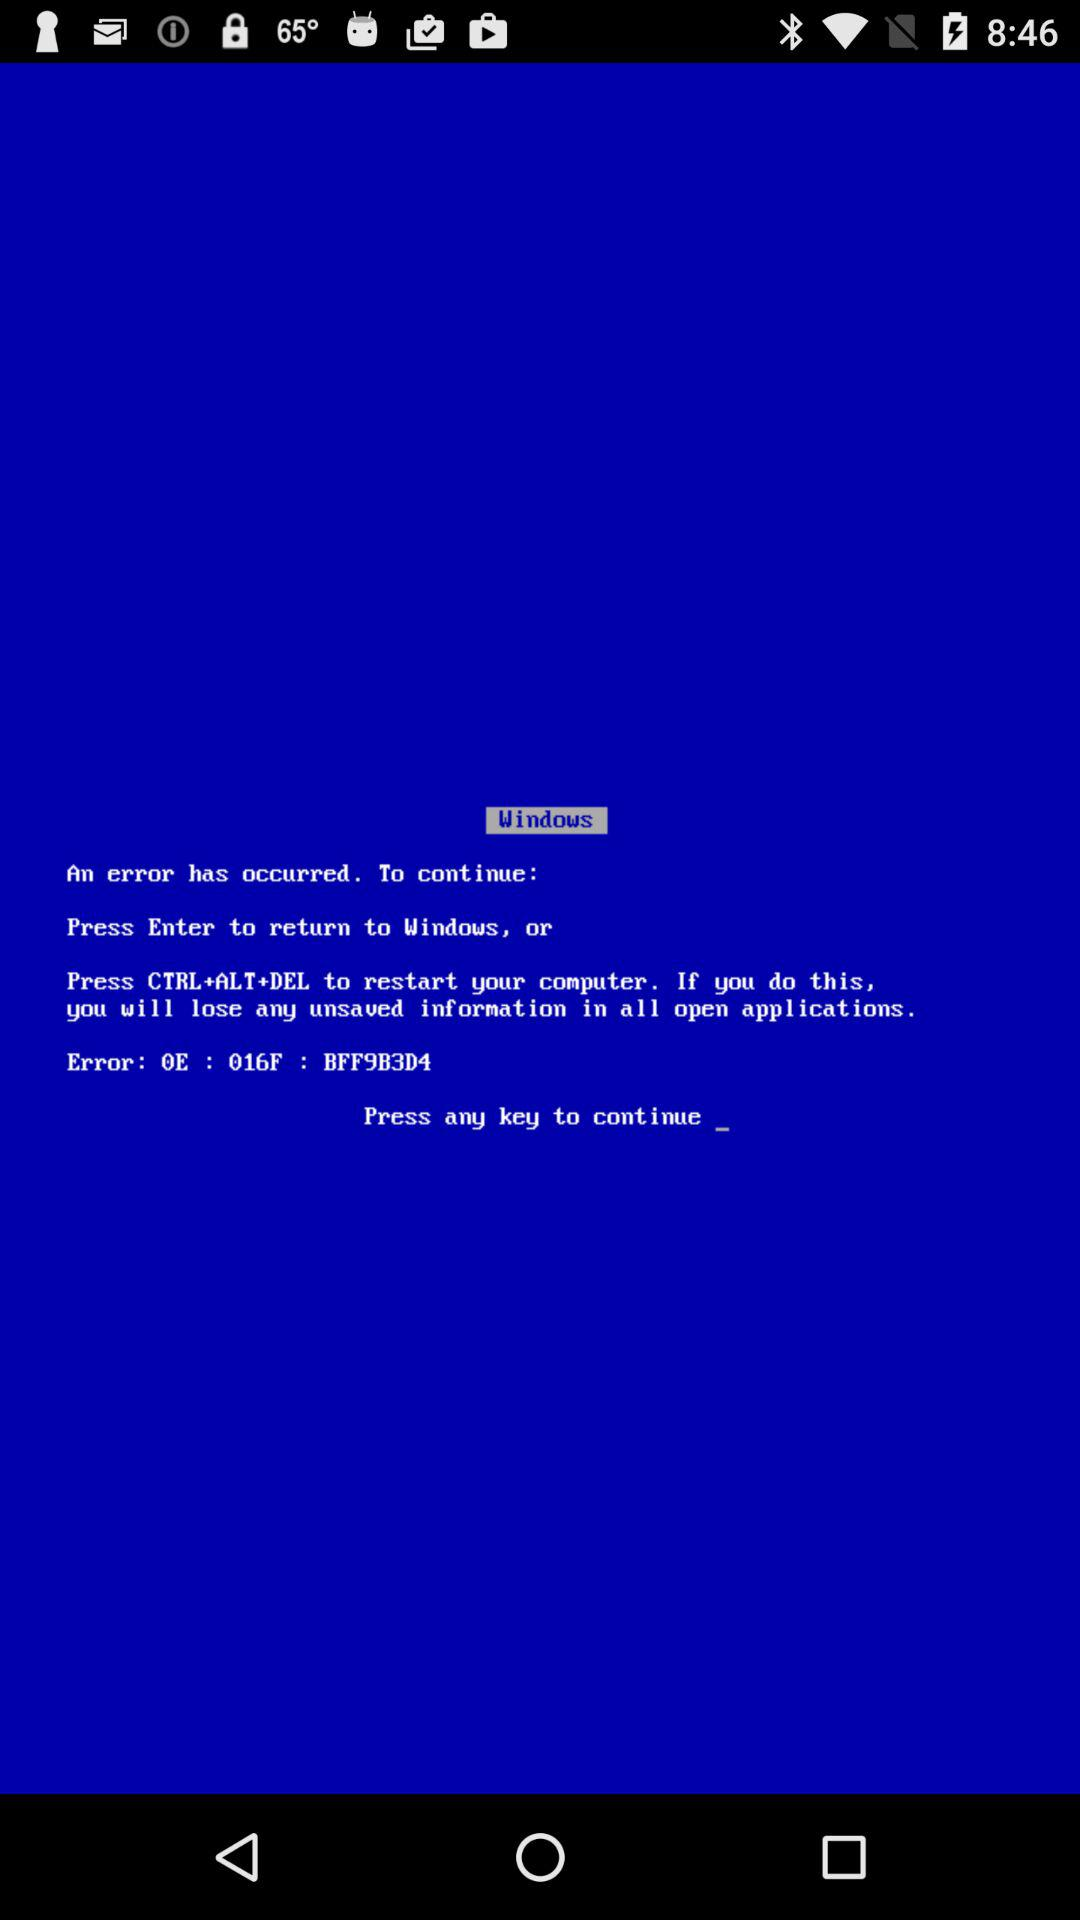Which keys have to be pressed to restart the computer? The keys that have to be pressed to restart the computer are Ctrl+Alt+Del. 